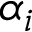<formula> <loc_0><loc_0><loc_500><loc_500>\alpha _ { i }</formula> 